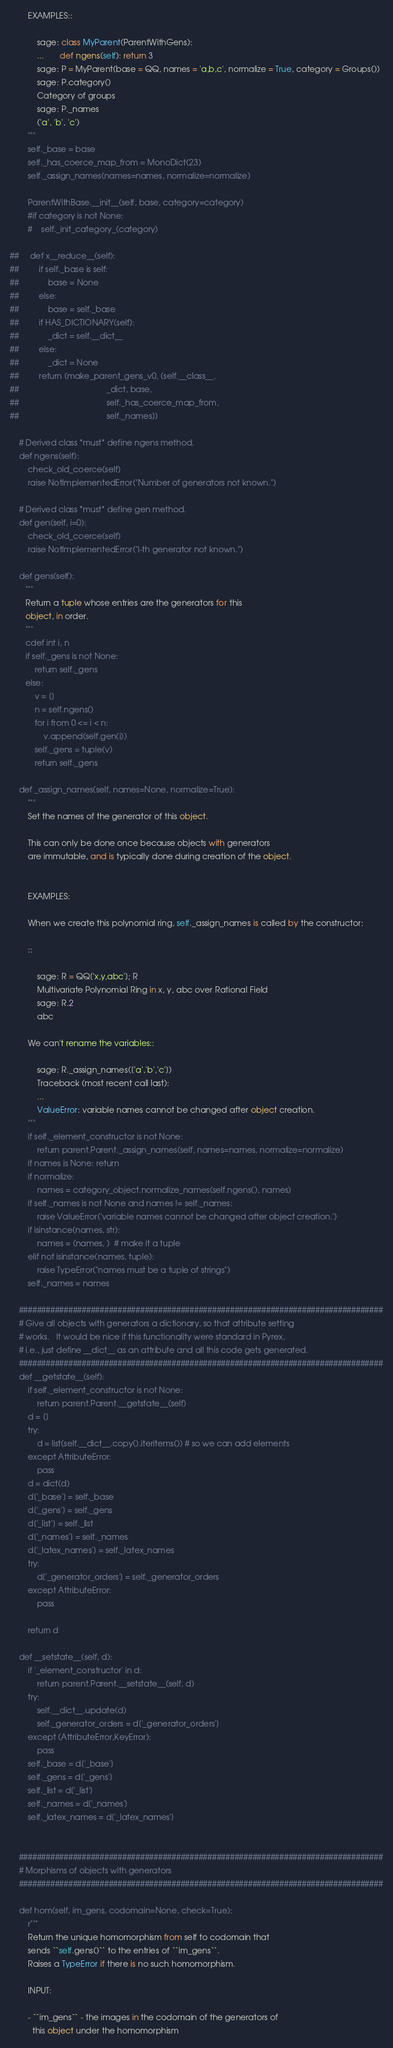<code> <loc_0><loc_0><loc_500><loc_500><_Cython_>        EXAMPLES::

            sage: class MyParent(ParentWithGens):
            ...       def ngens(self): return 3
            sage: P = MyParent(base = QQ, names = 'a,b,c', normalize = True, category = Groups())
            sage: P.category()
            Category of groups
            sage: P._names
            ('a', 'b', 'c')
        """
        self._base = base
        self._has_coerce_map_from = MonoDict(23)
        self._assign_names(names=names, normalize=normalize)

        ParentWithBase.__init__(self, base, category=category)
        #if category is not None:
        #    self._init_category_(category)

##     def x__reduce__(self):
##         if self._base is self:
##             base = None
##         else:
##             base = self._base
##         if HAS_DICTIONARY(self):
##             _dict = self.__dict__
##         else:
##             _dict = None
##         return (make_parent_gens_v0, (self.__class__,
##                                       _dict, base,
##                                       self._has_coerce_map_from,
##                                       self._names))

    # Derived class *must* define ngens method.
    def ngens(self):
        check_old_coerce(self)
        raise NotImplementedError("Number of generators not known.")

    # Derived class *must* define gen method.
    def gen(self, i=0):
        check_old_coerce(self)
        raise NotImplementedError("i-th generator not known.")

    def gens(self):
       """
       Return a tuple whose entries are the generators for this
       object, in order.
       """
       cdef int i, n
       if self._gens is not None:
           return self._gens
       else:
           v = []
           n = self.ngens()
           for i from 0 <= i < n:
               v.append(self.gen(i))
           self._gens = tuple(v)
           return self._gens

    def _assign_names(self, names=None, normalize=True):
        """
        Set the names of the generator of this object.

        This can only be done once because objects with generators
        are immutable, and is typically done during creation of the object.


        EXAMPLES:

        When we create this polynomial ring, self._assign_names is called by the constructor:

        ::

            sage: R = QQ['x,y,abc']; R
            Multivariate Polynomial Ring in x, y, abc over Rational Field
            sage: R.2
            abc

        We can't rename the variables::

            sage: R._assign_names(['a','b','c'])
            Traceback (most recent call last):
            ...
            ValueError: variable names cannot be changed after object creation.
        """
        if self._element_constructor is not None:
            return parent.Parent._assign_names(self, names=names, normalize=normalize)
        if names is None: return
        if normalize:
            names = category_object.normalize_names(self.ngens(), names)
        if self._names is not None and names != self._names:
            raise ValueError('variable names cannot be changed after object creation.')
        if isinstance(names, str):
            names = (names, )  # make it a tuple
        elif not isinstance(names, tuple):
            raise TypeError("names must be a tuple of strings")
        self._names = names

    #################################################################################
    # Give all objects with generators a dictionary, so that attribute setting
    # works.   It would be nice if this functionality were standard in Pyrex,
    # i.e., just define __dict__ as an attribute and all this code gets generated.
    #################################################################################
    def __getstate__(self):
        if self._element_constructor is not None:
            return parent.Parent.__getstate__(self)
        d = []
        try:
            d = list(self.__dict__.copy().iteritems()) # so we can add elements
        except AttributeError:
            pass
        d = dict(d)
        d['_base'] = self._base
        d['_gens'] = self._gens
        d['_list'] = self._list
        d['_names'] = self._names
        d['_latex_names'] = self._latex_names
        try:
            d['_generator_orders'] = self._generator_orders
        except AttributeError:
            pass

        return d

    def __setstate__(self, d):
        if '_element_constructor' in d:
            return parent.Parent.__setstate__(self, d)
        try:
            self.__dict__.update(d)
            self._generator_orders = d['_generator_orders']
        except (AttributeError,KeyError):
            pass
        self._base = d['_base']
        self._gens = d['_gens']
        self._list = d['_list']
        self._names = d['_names']
        self._latex_names = d['_latex_names']


    #################################################################################
    # Morphisms of objects with generators
    #################################################################################

    def hom(self, im_gens, codomain=None, check=True):
        r"""
        Return the unique homomorphism from self to codomain that
        sends ``self.gens()`` to the entries of ``im_gens``.
        Raises a TypeError if there is no such homomorphism.

        INPUT:

        - ``im_gens`` - the images in the codomain of the generators of
          this object under the homomorphism
</code> 